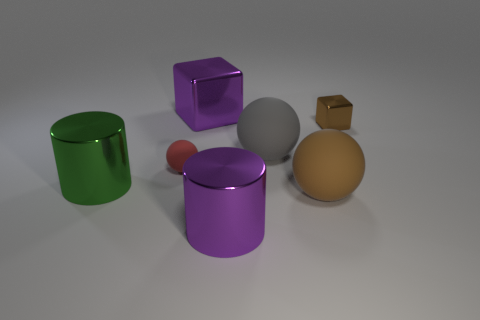What number of other objects are there of the same material as the large purple cylinder?
Offer a very short reply. 3. The green shiny object is what size?
Provide a short and direct response. Large. What number of other things are the same color as the large cube?
Your answer should be very brief. 1. The metal thing that is both on the left side of the small brown metallic object and on the right side of the purple block is what color?
Provide a short and direct response. Purple. How many small metallic spheres are there?
Provide a short and direct response. 0. Are the purple cylinder and the large cube made of the same material?
Your response must be concise. Yes. What shape is the small thing that is to the left of the cube that is in front of the purple thing left of the purple cylinder?
Offer a terse response. Sphere. Does the brown thing behind the green shiny cylinder have the same material as the object to the left of the small red matte sphere?
Make the answer very short. Yes. What material is the small sphere?
Ensure brevity in your answer.  Rubber. What number of big gray things have the same shape as the large brown matte thing?
Make the answer very short. 1. 